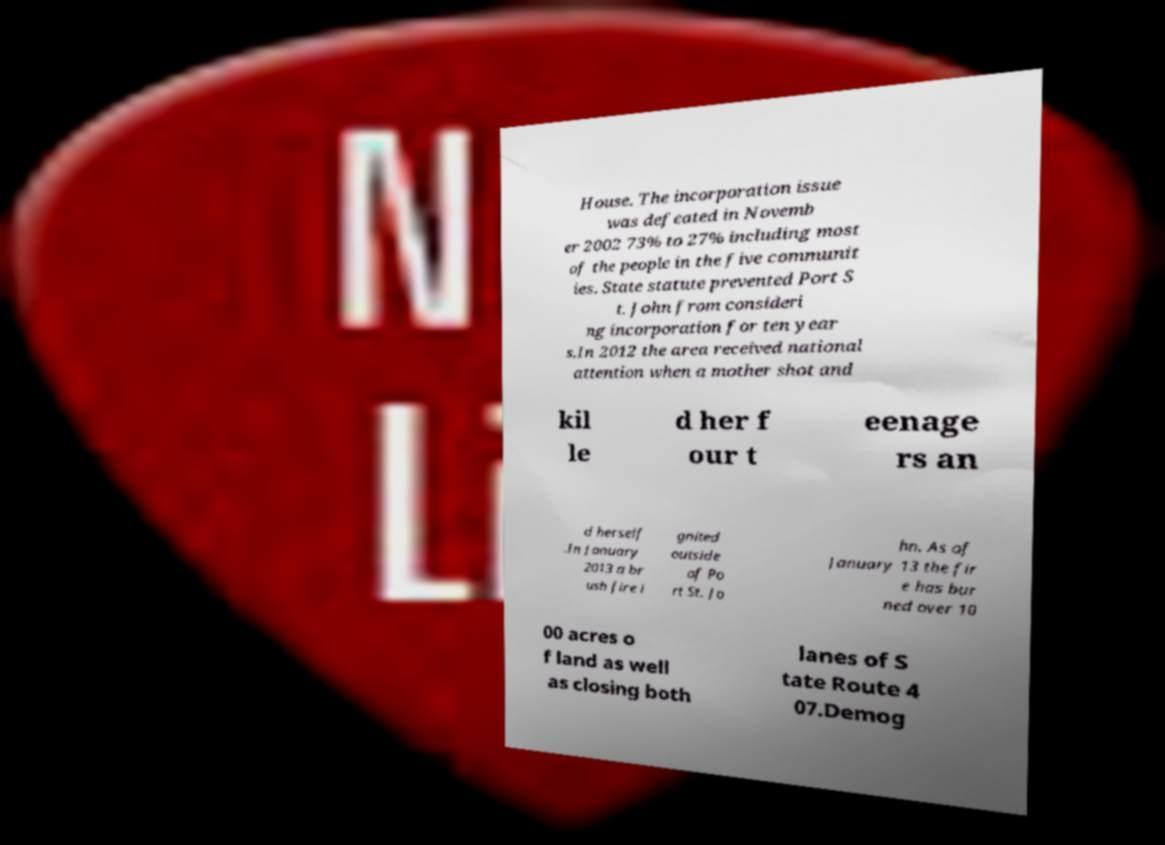What messages or text are displayed in this image? I need them in a readable, typed format. House. The incorporation issue was defeated in Novemb er 2002 73% to 27% including most of the people in the five communit ies. State statute prevented Port S t. John from consideri ng incorporation for ten year s.In 2012 the area received national attention when a mother shot and kil le d her f our t eenage rs an d herself .In January 2013 a br ush fire i gnited outside of Po rt St. Jo hn. As of January 13 the fir e has bur ned over 10 00 acres o f land as well as closing both lanes of S tate Route 4 07.Demog 